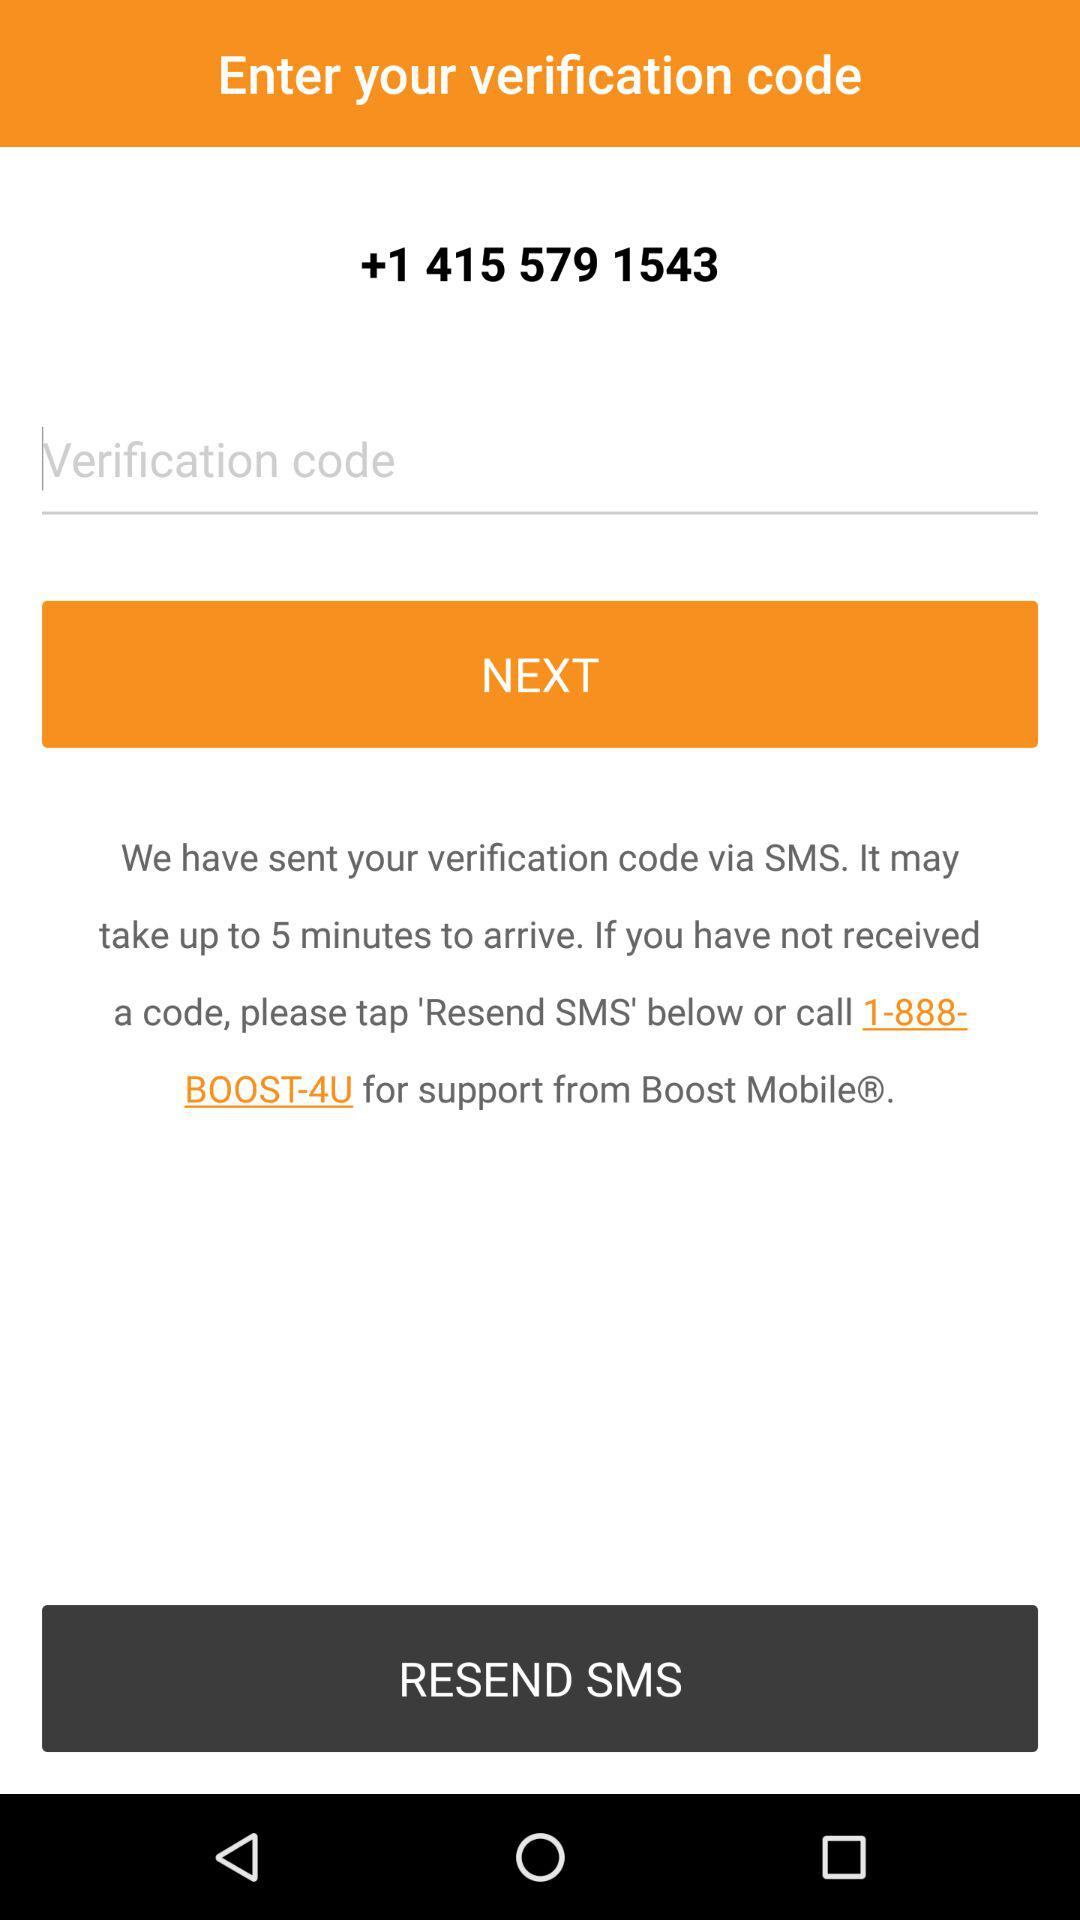How much time will it take for the verification code to arrive? The verification code may take up to 5 minutes to arrive. 